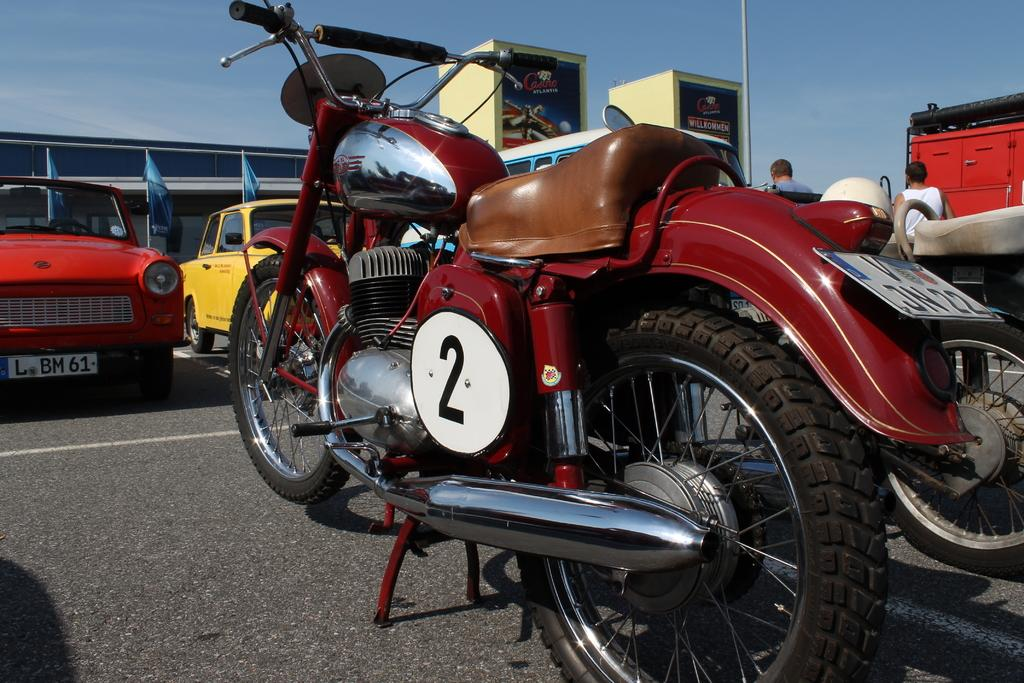Provide a one-sentence caption for the provided image. A vintage motorcycle has a number 2 placard on its side. 